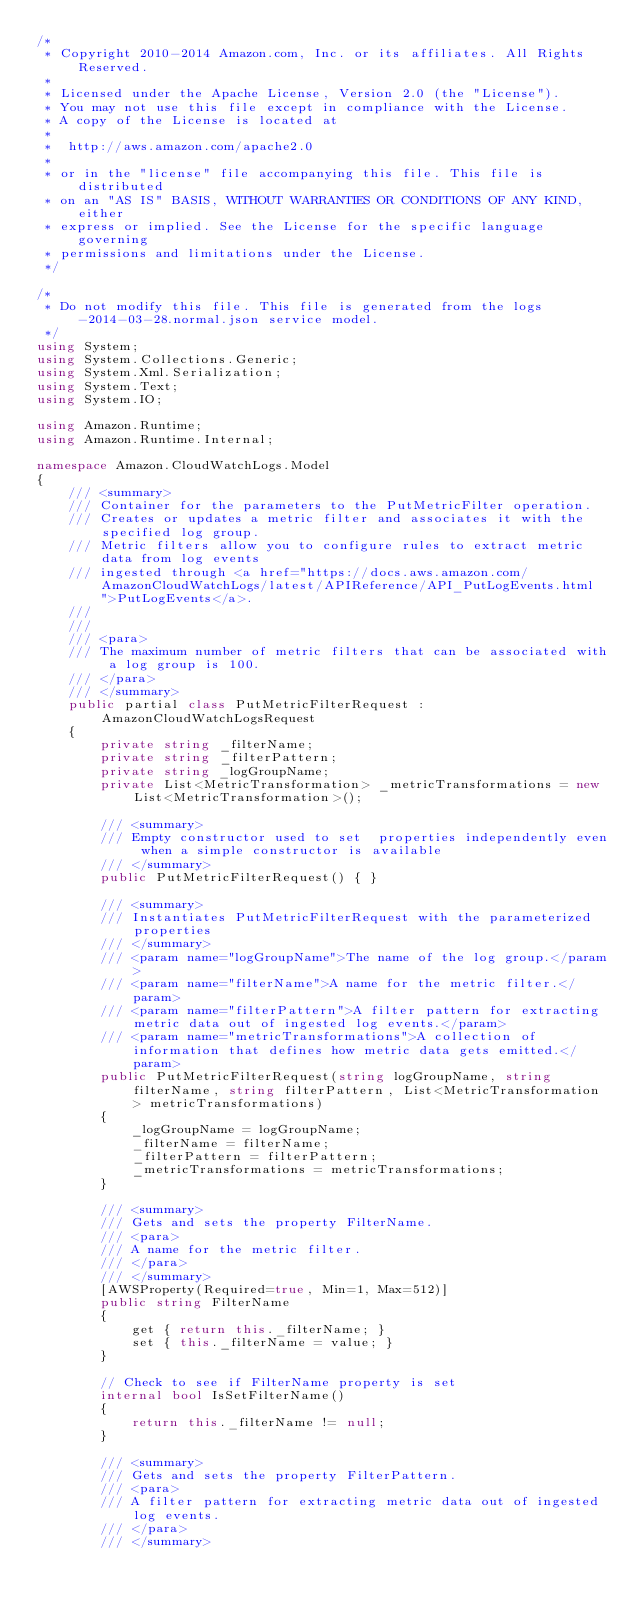<code> <loc_0><loc_0><loc_500><loc_500><_C#_>/*
 * Copyright 2010-2014 Amazon.com, Inc. or its affiliates. All Rights Reserved.
 * 
 * Licensed under the Apache License, Version 2.0 (the "License").
 * You may not use this file except in compliance with the License.
 * A copy of the License is located at
 * 
 *  http://aws.amazon.com/apache2.0
 * 
 * or in the "license" file accompanying this file. This file is distributed
 * on an "AS IS" BASIS, WITHOUT WARRANTIES OR CONDITIONS OF ANY KIND, either
 * express or implied. See the License for the specific language governing
 * permissions and limitations under the License.
 */

/*
 * Do not modify this file. This file is generated from the logs-2014-03-28.normal.json service model.
 */
using System;
using System.Collections.Generic;
using System.Xml.Serialization;
using System.Text;
using System.IO;

using Amazon.Runtime;
using Amazon.Runtime.Internal;

namespace Amazon.CloudWatchLogs.Model
{
    /// <summary>
    /// Container for the parameters to the PutMetricFilter operation.
    /// Creates or updates a metric filter and associates it with the specified log group.
    /// Metric filters allow you to configure rules to extract metric data from log events
    /// ingested through <a href="https://docs.aws.amazon.com/AmazonCloudWatchLogs/latest/APIReference/API_PutLogEvents.html">PutLogEvents</a>.
    /// 
    ///  
    /// <para>
    /// The maximum number of metric filters that can be associated with a log group is 100.
    /// </para>
    /// </summary>
    public partial class PutMetricFilterRequest : AmazonCloudWatchLogsRequest
    {
        private string _filterName;
        private string _filterPattern;
        private string _logGroupName;
        private List<MetricTransformation> _metricTransformations = new List<MetricTransformation>();

        /// <summary>
        /// Empty constructor used to set  properties independently even when a simple constructor is available
        /// </summary>
        public PutMetricFilterRequest() { }

        /// <summary>
        /// Instantiates PutMetricFilterRequest with the parameterized properties
        /// </summary>
        /// <param name="logGroupName">The name of the log group.</param>
        /// <param name="filterName">A name for the metric filter.</param>
        /// <param name="filterPattern">A filter pattern for extracting metric data out of ingested log events.</param>
        /// <param name="metricTransformations">A collection of information that defines how metric data gets emitted.</param>
        public PutMetricFilterRequest(string logGroupName, string filterName, string filterPattern, List<MetricTransformation> metricTransformations)
        {
            _logGroupName = logGroupName;
            _filterName = filterName;
            _filterPattern = filterPattern;
            _metricTransformations = metricTransformations;
        }

        /// <summary>
        /// Gets and sets the property FilterName. 
        /// <para>
        /// A name for the metric filter.
        /// </para>
        /// </summary>
        [AWSProperty(Required=true, Min=1, Max=512)]
        public string FilterName
        {
            get { return this._filterName; }
            set { this._filterName = value; }
        }

        // Check to see if FilterName property is set
        internal bool IsSetFilterName()
        {
            return this._filterName != null;
        }

        /// <summary>
        /// Gets and sets the property FilterPattern. 
        /// <para>
        /// A filter pattern for extracting metric data out of ingested log events.
        /// </para>
        /// </summary></code> 